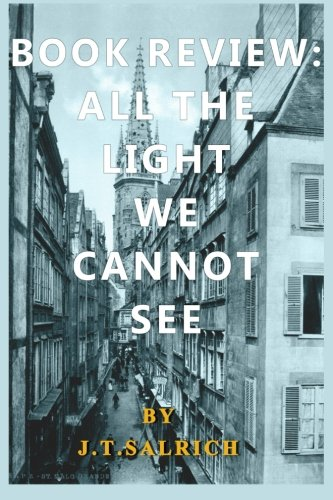What is the title of this book? The title of the book is 'All the Light We Cannot See,' although the text on the cover also suggests a review. It's a popular award-winning novel. 